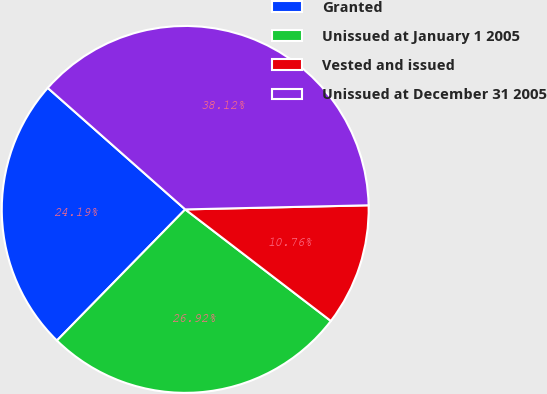<chart> <loc_0><loc_0><loc_500><loc_500><pie_chart><fcel>Granted<fcel>Unissued at January 1 2005<fcel>Vested and issued<fcel>Unissued at December 31 2005<nl><fcel>24.19%<fcel>26.92%<fcel>10.76%<fcel>38.12%<nl></chart> 